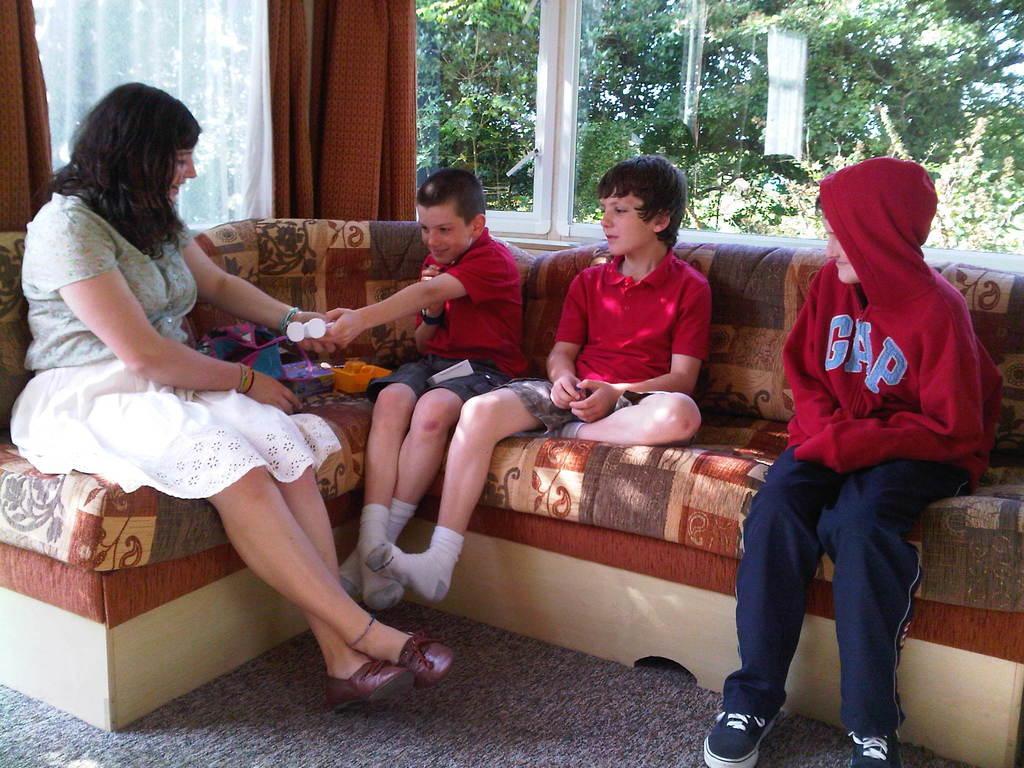Please provide a concise description of this image. In this image there is a woman sitting on the sofa. Beside her there are three kids sitting on the sofa. The woman is giving the toys to the kid who is beside her. In the background there is a glass window with the curtains. Through the window we can see the trees. On the floor there is carpet. 